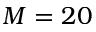<formula> <loc_0><loc_0><loc_500><loc_500>M = 2 0</formula> 